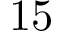Convert formula to latex. <formula><loc_0><loc_0><loc_500><loc_500>1 5</formula> 